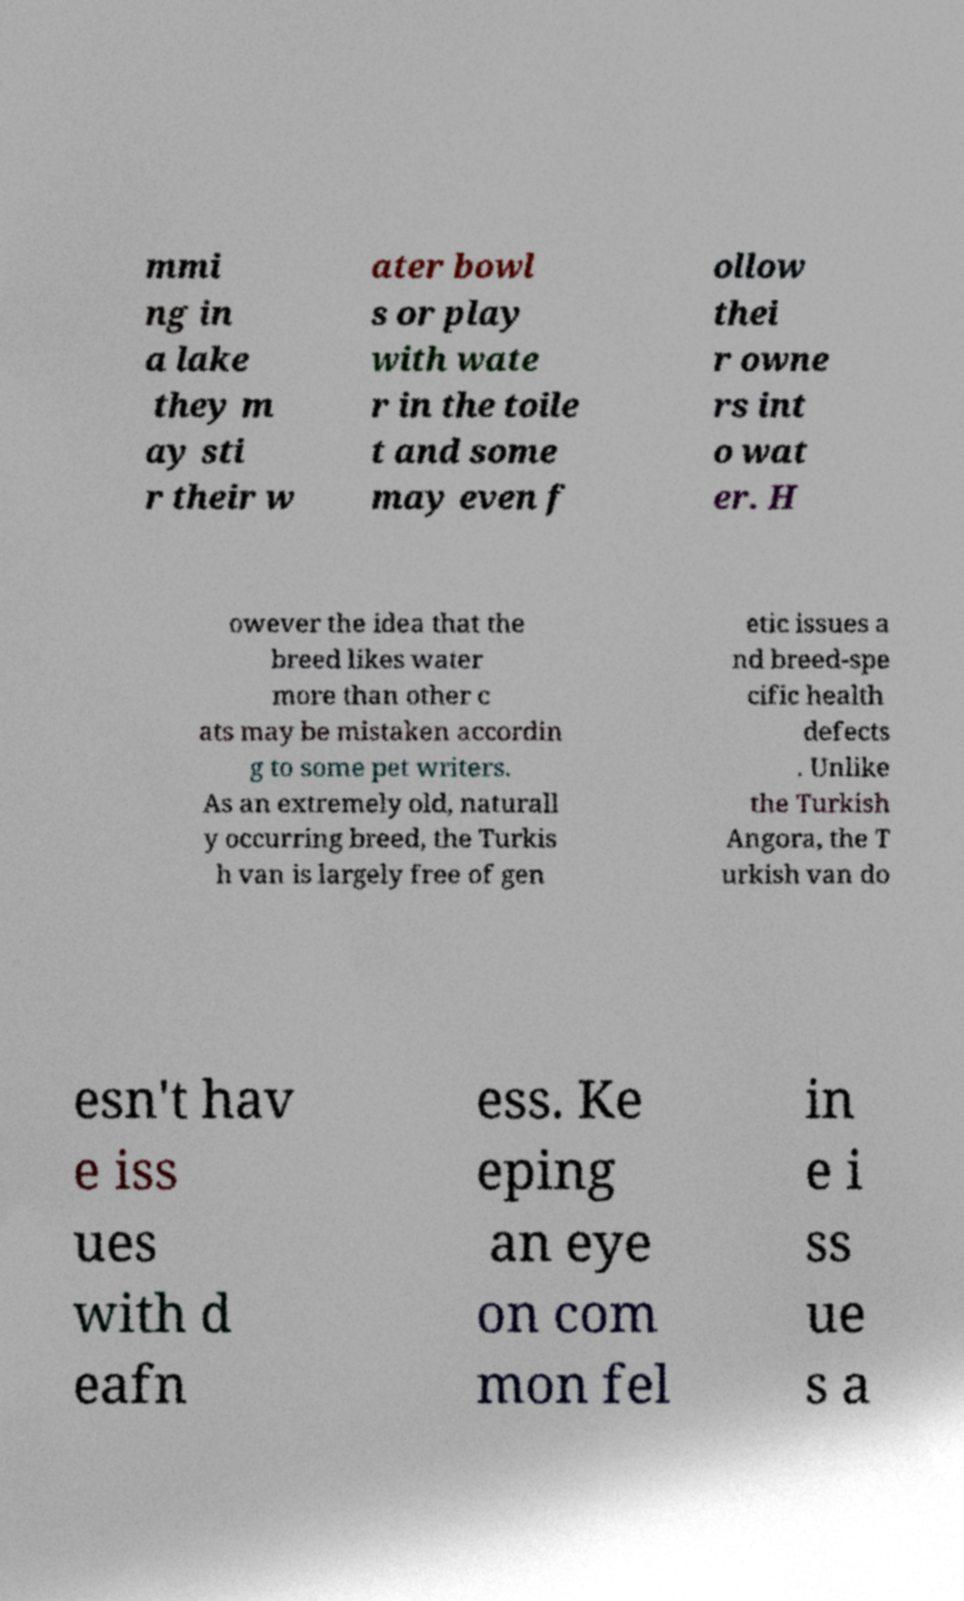Can you read and provide the text displayed in the image?This photo seems to have some interesting text. Can you extract and type it out for me? mmi ng in a lake they m ay sti r their w ater bowl s or play with wate r in the toile t and some may even f ollow thei r owne rs int o wat er. H owever the idea that the breed likes water more than other c ats may be mistaken accordin g to some pet writers. As an extremely old, naturall y occurring breed, the Turkis h van is largely free of gen etic issues a nd breed-spe cific health defects . Unlike the Turkish Angora, the T urkish van do esn't hav e iss ues with d eafn ess. Ke eping an eye on com mon fel in e i ss ue s a 